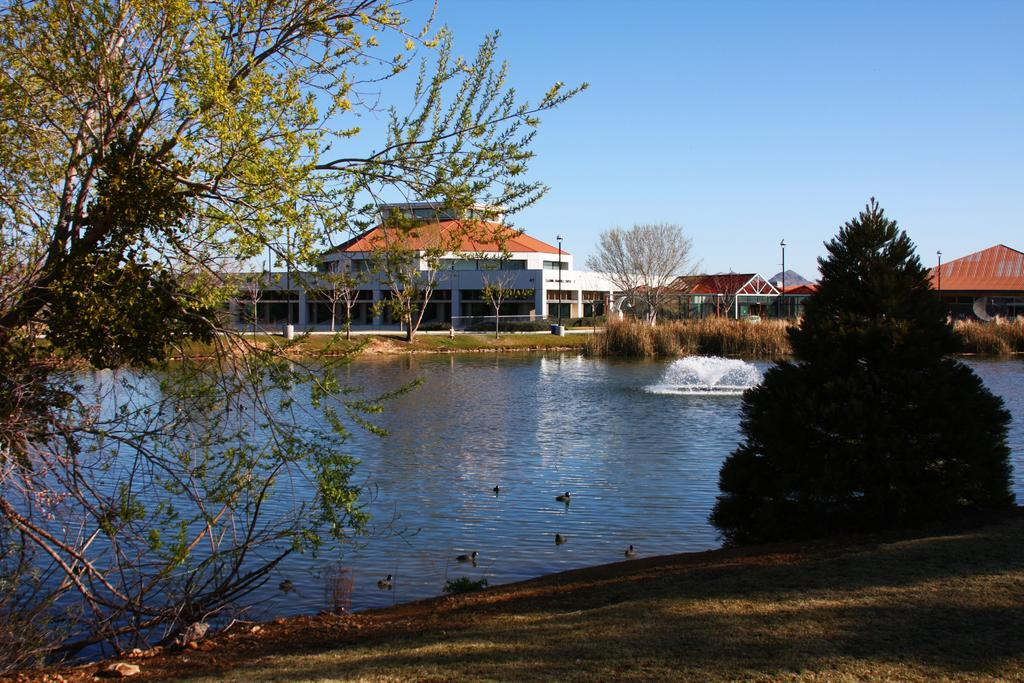What type of vegetation can be seen in the image? There are trees in green color in the image. What is the main feature in the center of the image? There is a fountain in the image. What colors are the buildings in the image? The buildings in the image are in white and brown color. What structures are present to provide light at night? There are light poles in the image. What color is the sky in the image? The sky is in blue color in the image. What type of heart-shaped object can be seen in the image? There is no heart-shaped object present in the image. What type of frame surrounds the image? The image does not show a frame; it is a photograph or digital image itself. 